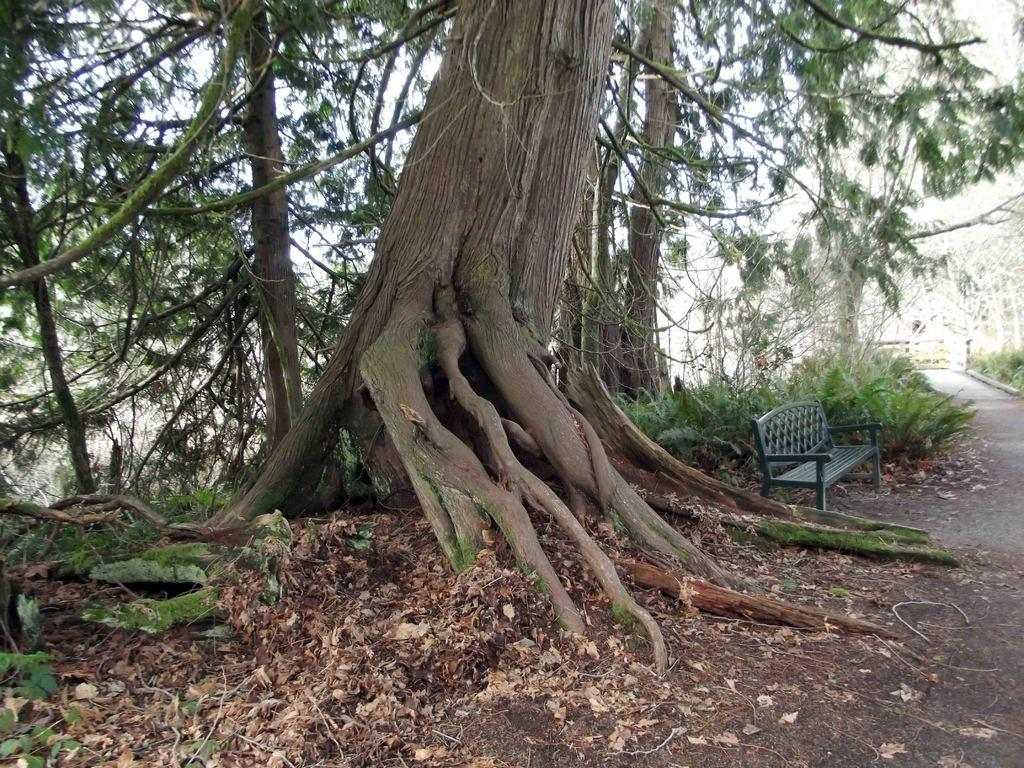What is located in the center of the image? There is a fence in the center of the image. What can be found near the fence? There is a bench in the image. What type of pathway is visible in the image? There is a road in the image. What type of vegetation is present in the image? There are trees, plants, and grass in the image. What additional detail can be observed on the ground? Dry leaves are present in the image. What type of kite is being flown by the apple in the image? There is no kite or apple present in the image. 